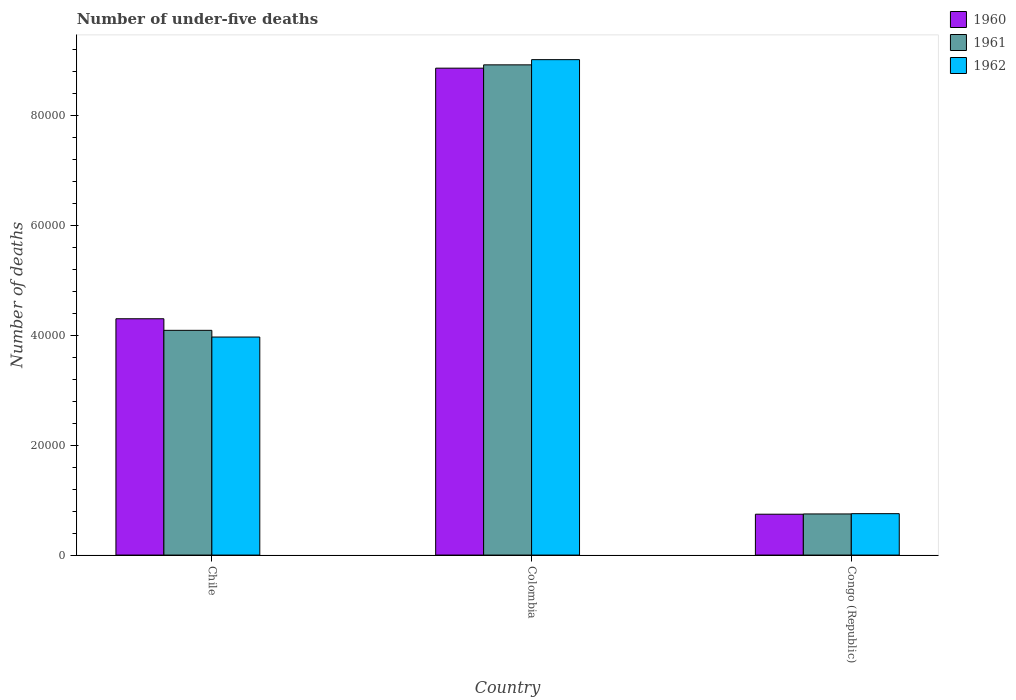How many different coloured bars are there?
Your response must be concise. 3. Are the number of bars per tick equal to the number of legend labels?
Give a very brief answer. Yes. In how many cases, is the number of bars for a given country not equal to the number of legend labels?
Keep it short and to the point. 0. What is the number of under-five deaths in 1961 in Chile?
Your answer should be very brief. 4.09e+04. Across all countries, what is the maximum number of under-five deaths in 1961?
Your answer should be very brief. 8.92e+04. Across all countries, what is the minimum number of under-five deaths in 1960?
Ensure brevity in your answer.  7431. In which country was the number of under-five deaths in 1962 maximum?
Your answer should be compact. Colombia. In which country was the number of under-five deaths in 1962 minimum?
Provide a short and direct response. Congo (Republic). What is the total number of under-five deaths in 1961 in the graph?
Provide a short and direct response. 1.38e+05. What is the difference between the number of under-five deaths in 1962 in Chile and that in Congo (Republic)?
Your answer should be very brief. 3.21e+04. What is the difference between the number of under-five deaths in 1962 in Congo (Republic) and the number of under-five deaths in 1961 in Chile?
Give a very brief answer. -3.33e+04. What is the average number of under-five deaths in 1960 per country?
Provide a short and direct response. 4.63e+04. What is the difference between the number of under-five deaths of/in 1962 and number of under-five deaths of/in 1960 in Congo (Republic)?
Provide a short and direct response. 99. What is the ratio of the number of under-five deaths in 1962 in Chile to that in Colombia?
Your answer should be compact. 0.44. What is the difference between the highest and the second highest number of under-five deaths in 1962?
Provide a short and direct response. 8.26e+04. What is the difference between the highest and the lowest number of under-five deaths in 1960?
Give a very brief answer. 8.11e+04. Is the sum of the number of under-five deaths in 1960 in Colombia and Congo (Republic) greater than the maximum number of under-five deaths in 1961 across all countries?
Offer a very short reply. Yes. Are all the bars in the graph horizontal?
Give a very brief answer. No. How many countries are there in the graph?
Your response must be concise. 3. What is the difference between two consecutive major ticks on the Y-axis?
Provide a short and direct response. 2.00e+04. Does the graph contain grids?
Make the answer very short. No. How are the legend labels stacked?
Your response must be concise. Vertical. What is the title of the graph?
Offer a very short reply. Number of under-five deaths. What is the label or title of the X-axis?
Your answer should be compact. Country. What is the label or title of the Y-axis?
Offer a very short reply. Number of deaths. What is the Number of deaths of 1960 in Chile?
Give a very brief answer. 4.30e+04. What is the Number of deaths in 1961 in Chile?
Offer a terse response. 4.09e+04. What is the Number of deaths of 1962 in Chile?
Your response must be concise. 3.97e+04. What is the Number of deaths of 1960 in Colombia?
Keep it short and to the point. 8.86e+04. What is the Number of deaths of 1961 in Colombia?
Offer a terse response. 8.92e+04. What is the Number of deaths in 1962 in Colombia?
Provide a short and direct response. 9.01e+04. What is the Number of deaths of 1960 in Congo (Republic)?
Give a very brief answer. 7431. What is the Number of deaths in 1961 in Congo (Republic)?
Give a very brief answer. 7480. What is the Number of deaths in 1962 in Congo (Republic)?
Your response must be concise. 7530. Across all countries, what is the maximum Number of deaths in 1960?
Offer a very short reply. 8.86e+04. Across all countries, what is the maximum Number of deaths in 1961?
Make the answer very short. 8.92e+04. Across all countries, what is the maximum Number of deaths of 1962?
Provide a short and direct response. 9.01e+04. Across all countries, what is the minimum Number of deaths of 1960?
Offer a very short reply. 7431. Across all countries, what is the minimum Number of deaths of 1961?
Offer a very short reply. 7480. Across all countries, what is the minimum Number of deaths in 1962?
Ensure brevity in your answer.  7530. What is the total Number of deaths in 1960 in the graph?
Ensure brevity in your answer.  1.39e+05. What is the total Number of deaths of 1961 in the graph?
Ensure brevity in your answer.  1.38e+05. What is the total Number of deaths of 1962 in the graph?
Provide a succinct answer. 1.37e+05. What is the difference between the Number of deaths in 1960 in Chile and that in Colombia?
Ensure brevity in your answer.  -4.56e+04. What is the difference between the Number of deaths in 1961 in Chile and that in Colombia?
Make the answer very short. -4.83e+04. What is the difference between the Number of deaths in 1962 in Chile and that in Colombia?
Provide a short and direct response. -5.04e+04. What is the difference between the Number of deaths in 1960 in Chile and that in Congo (Republic)?
Provide a succinct answer. 3.55e+04. What is the difference between the Number of deaths in 1961 in Chile and that in Congo (Republic)?
Make the answer very short. 3.34e+04. What is the difference between the Number of deaths in 1962 in Chile and that in Congo (Republic)?
Provide a short and direct response. 3.21e+04. What is the difference between the Number of deaths in 1960 in Colombia and that in Congo (Republic)?
Offer a terse response. 8.11e+04. What is the difference between the Number of deaths of 1961 in Colombia and that in Congo (Republic)?
Make the answer very short. 8.17e+04. What is the difference between the Number of deaths in 1962 in Colombia and that in Congo (Republic)?
Provide a succinct answer. 8.26e+04. What is the difference between the Number of deaths of 1960 in Chile and the Number of deaths of 1961 in Colombia?
Ensure brevity in your answer.  -4.62e+04. What is the difference between the Number of deaths of 1960 in Chile and the Number of deaths of 1962 in Colombia?
Offer a very short reply. -4.71e+04. What is the difference between the Number of deaths of 1961 in Chile and the Number of deaths of 1962 in Colombia?
Your answer should be compact. -4.92e+04. What is the difference between the Number of deaths in 1960 in Chile and the Number of deaths in 1961 in Congo (Republic)?
Offer a very short reply. 3.55e+04. What is the difference between the Number of deaths of 1960 in Chile and the Number of deaths of 1962 in Congo (Republic)?
Make the answer very short. 3.54e+04. What is the difference between the Number of deaths in 1961 in Chile and the Number of deaths in 1962 in Congo (Republic)?
Provide a succinct answer. 3.33e+04. What is the difference between the Number of deaths of 1960 in Colombia and the Number of deaths of 1961 in Congo (Republic)?
Your response must be concise. 8.11e+04. What is the difference between the Number of deaths in 1960 in Colombia and the Number of deaths in 1962 in Congo (Republic)?
Your response must be concise. 8.10e+04. What is the difference between the Number of deaths of 1961 in Colombia and the Number of deaths of 1962 in Congo (Republic)?
Ensure brevity in your answer.  8.16e+04. What is the average Number of deaths of 1960 per country?
Your answer should be compact. 4.63e+04. What is the average Number of deaths in 1961 per country?
Provide a short and direct response. 4.58e+04. What is the average Number of deaths in 1962 per country?
Your answer should be very brief. 4.58e+04. What is the difference between the Number of deaths in 1960 and Number of deaths in 1961 in Chile?
Make the answer very short. 2108. What is the difference between the Number of deaths of 1960 and Number of deaths of 1962 in Chile?
Offer a very short reply. 3325. What is the difference between the Number of deaths in 1961 and Number of deaths in 1962 in Chile?
Give a very brief answer. 1217. What is the difference between the Number of deaths of 1960 and Number of deaths of 1961 in Colombia?
Offer a very short reply. -600. What is the difference between the Number of deaths in 1960 and Number of deaths in 1962 in Colombia?
Your response must be concise. -1548. What is the difference between the Number of deaths in 1961 and Number of deaths in 1962 in Colombia?
Offer a very short reply. -948. What is the difference between the Number of deaths in 1960 and Number of deaths in 1961 in Congo (Republic)?
Provide a short and direct response. -49. What is the difference between the Number of deaths of 1960 and Number of deaths of 1962 in Congo (Republic)?
Offer a terse response. -99. What is the ratio of the Number of deaths of 1960 in Chile to that in Colombia?
Offer a terse response. 0.49. What is the ratio of the Number of deaths in 1961 in Chile to that in Colombia?
Give a very brief answer. 0.46. What is the ratio of the Number of deaths of 1962 in Chile to that in Colombia?
Provide a short and direct response. 0.44. What is the ratio of the Number of deaths of 1960 in Chile to that in Congo (Republic)?
Keep it short and to the point. 5.78. What is the ratio of the Number of deaths of 1961 in Chile to that in Congo (Republic)?
Give a very brief answer. 5.46. What is the ratio of the Number of deaths in 1962 in Chile to that in Congo (Republic)?
Offer a terse response. 5.27. What is the ratio of the Number of deaths of 1960 in Colombia to that in Congo (Republic)?
Offer a very short reply. 11.92. What is the ratio of the Number of deaths of 1961 in Colombia to that in Congo (Republic)?
Provide a short and direct response. 11.92. What is the ratio of the Number of deaths of 1962 in Colombia to that in Congo (Republic)?
Provide a short and direct response. 11.97. What is the difference between the highest and the second highest Number of deaths in 1960?
Keep it short and to the point. 4.56e+04. What is the difference between the highest and the second highest Number of deaths in 1961?
Your response must be concise. 4.83e+04. What is the difference between the highest and the second highest Number of deaths of 1962?
Offer a terse response. 5.04e+04. What is the difference between the highest and the lowest Number of deaths of 1960?
Your answer should be very brief. 8.11e+04. What is the difference between the highest and the lowest Number of deaths in 1961?
Provide a short and direct response. 8.17e+04. What is the difference between the highest and the lowest Number of deaths in 1962?
Provide a short and direct response. 8.26e+04. 